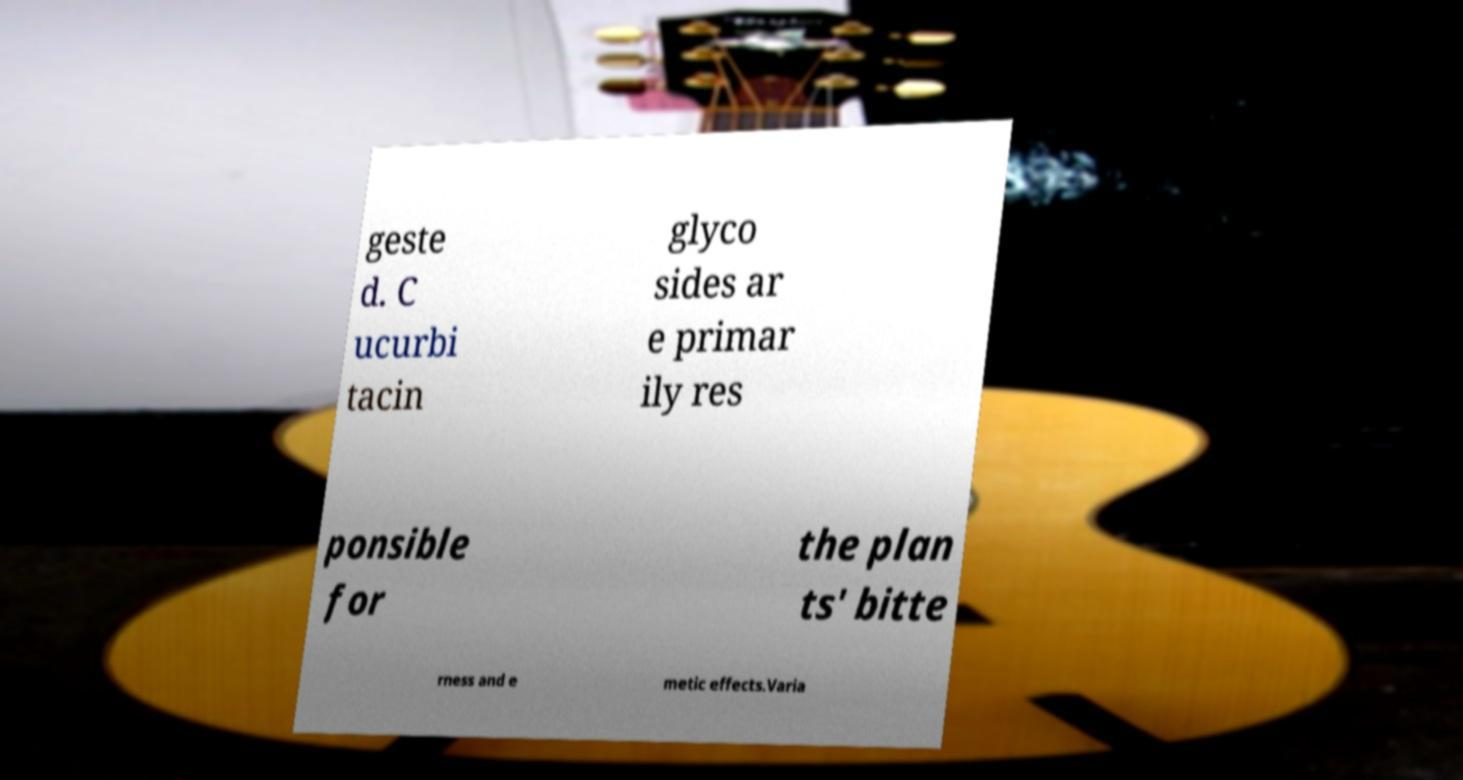Can you read and provide the text displayed in the image?This photo seems to have some interesting text. Can you extract and type it out for me? geste d. C ucurbi tacin glyco sides ar e primar ily res ponsible for the plan ts' bitte rness and e metic effects.Varia 